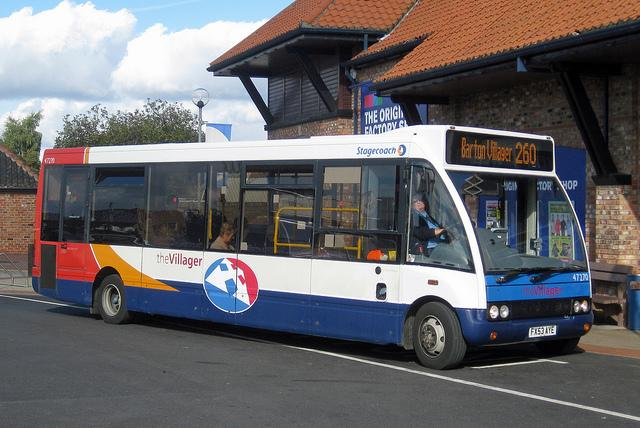Where does this bus stop here?

Choices:
A) school
B) crosswalk
C) outlet mall
D) church outlet mall 